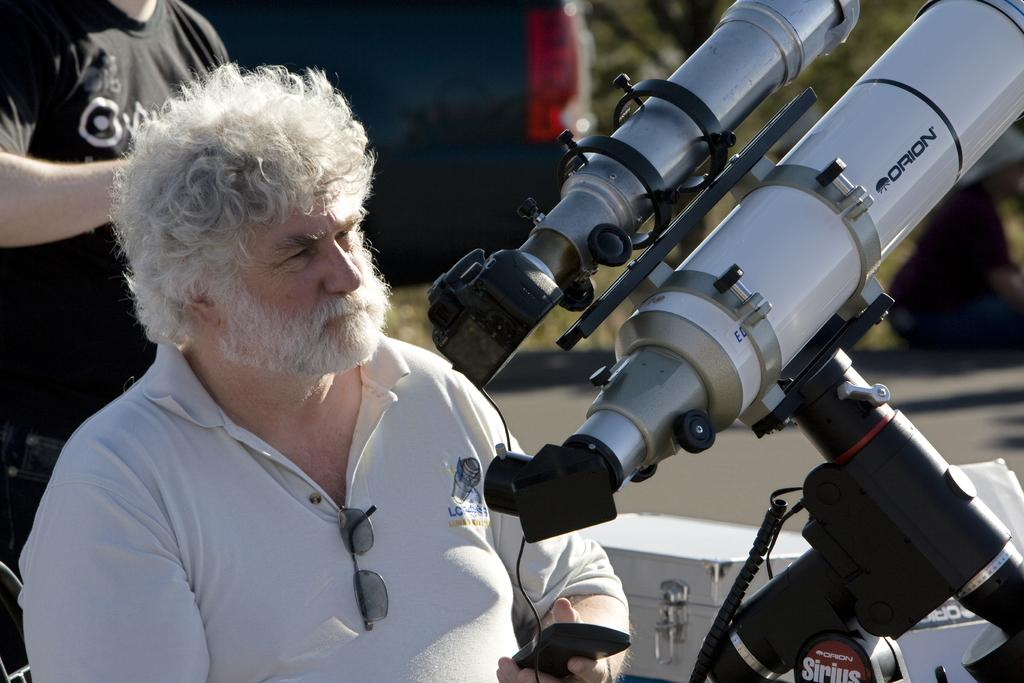What is located on the left side of the image? There is a man on the left side of the image. What is the man wearing? The man is wearing a t-shirt. What can be seen on the right side of the image? There is a camera on the right side of the image. What is near the camera? There is a stand near the camera. What else can be observed in the image? Cables are present in the image. What is visible in the background of the image? There are people, a vehicle, boxes, a road, and plants in the background. How many straws are being used by the spiders in the image? There are no spiders or straws present in the image. What part of the man's body is visible in the image? The provided facts do not specify which part of the man's body is visible in the image. 